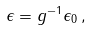<formula> <loc_0><loc_0><loc_500><loc_500>\epsilon = g ^ { - 1 } \epsilon _ { 0 } \, ,</formula> 